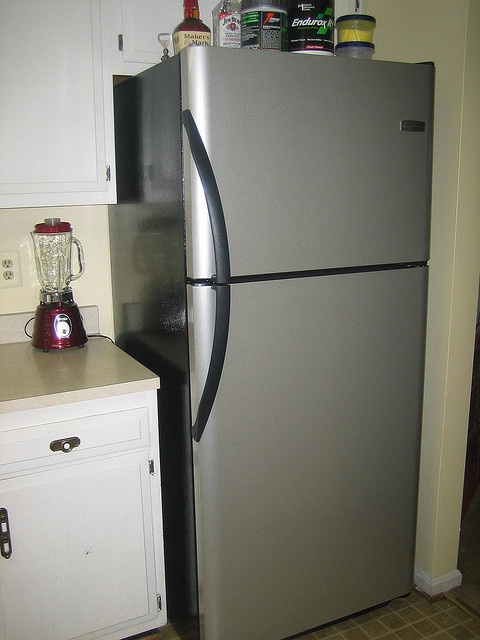Describe the objects in this image and their specific colors. I can see refrigerator in darkgray, gray, and black tones, bottle in darkgray, black, gray, and darkgreen tones, bottle in darkgray, black, gray, and darkgreen tones, bottle in darkgray, gray, and lightgray tones, and bottle in darkgray, maroon, tan, and gray tones in this image. 